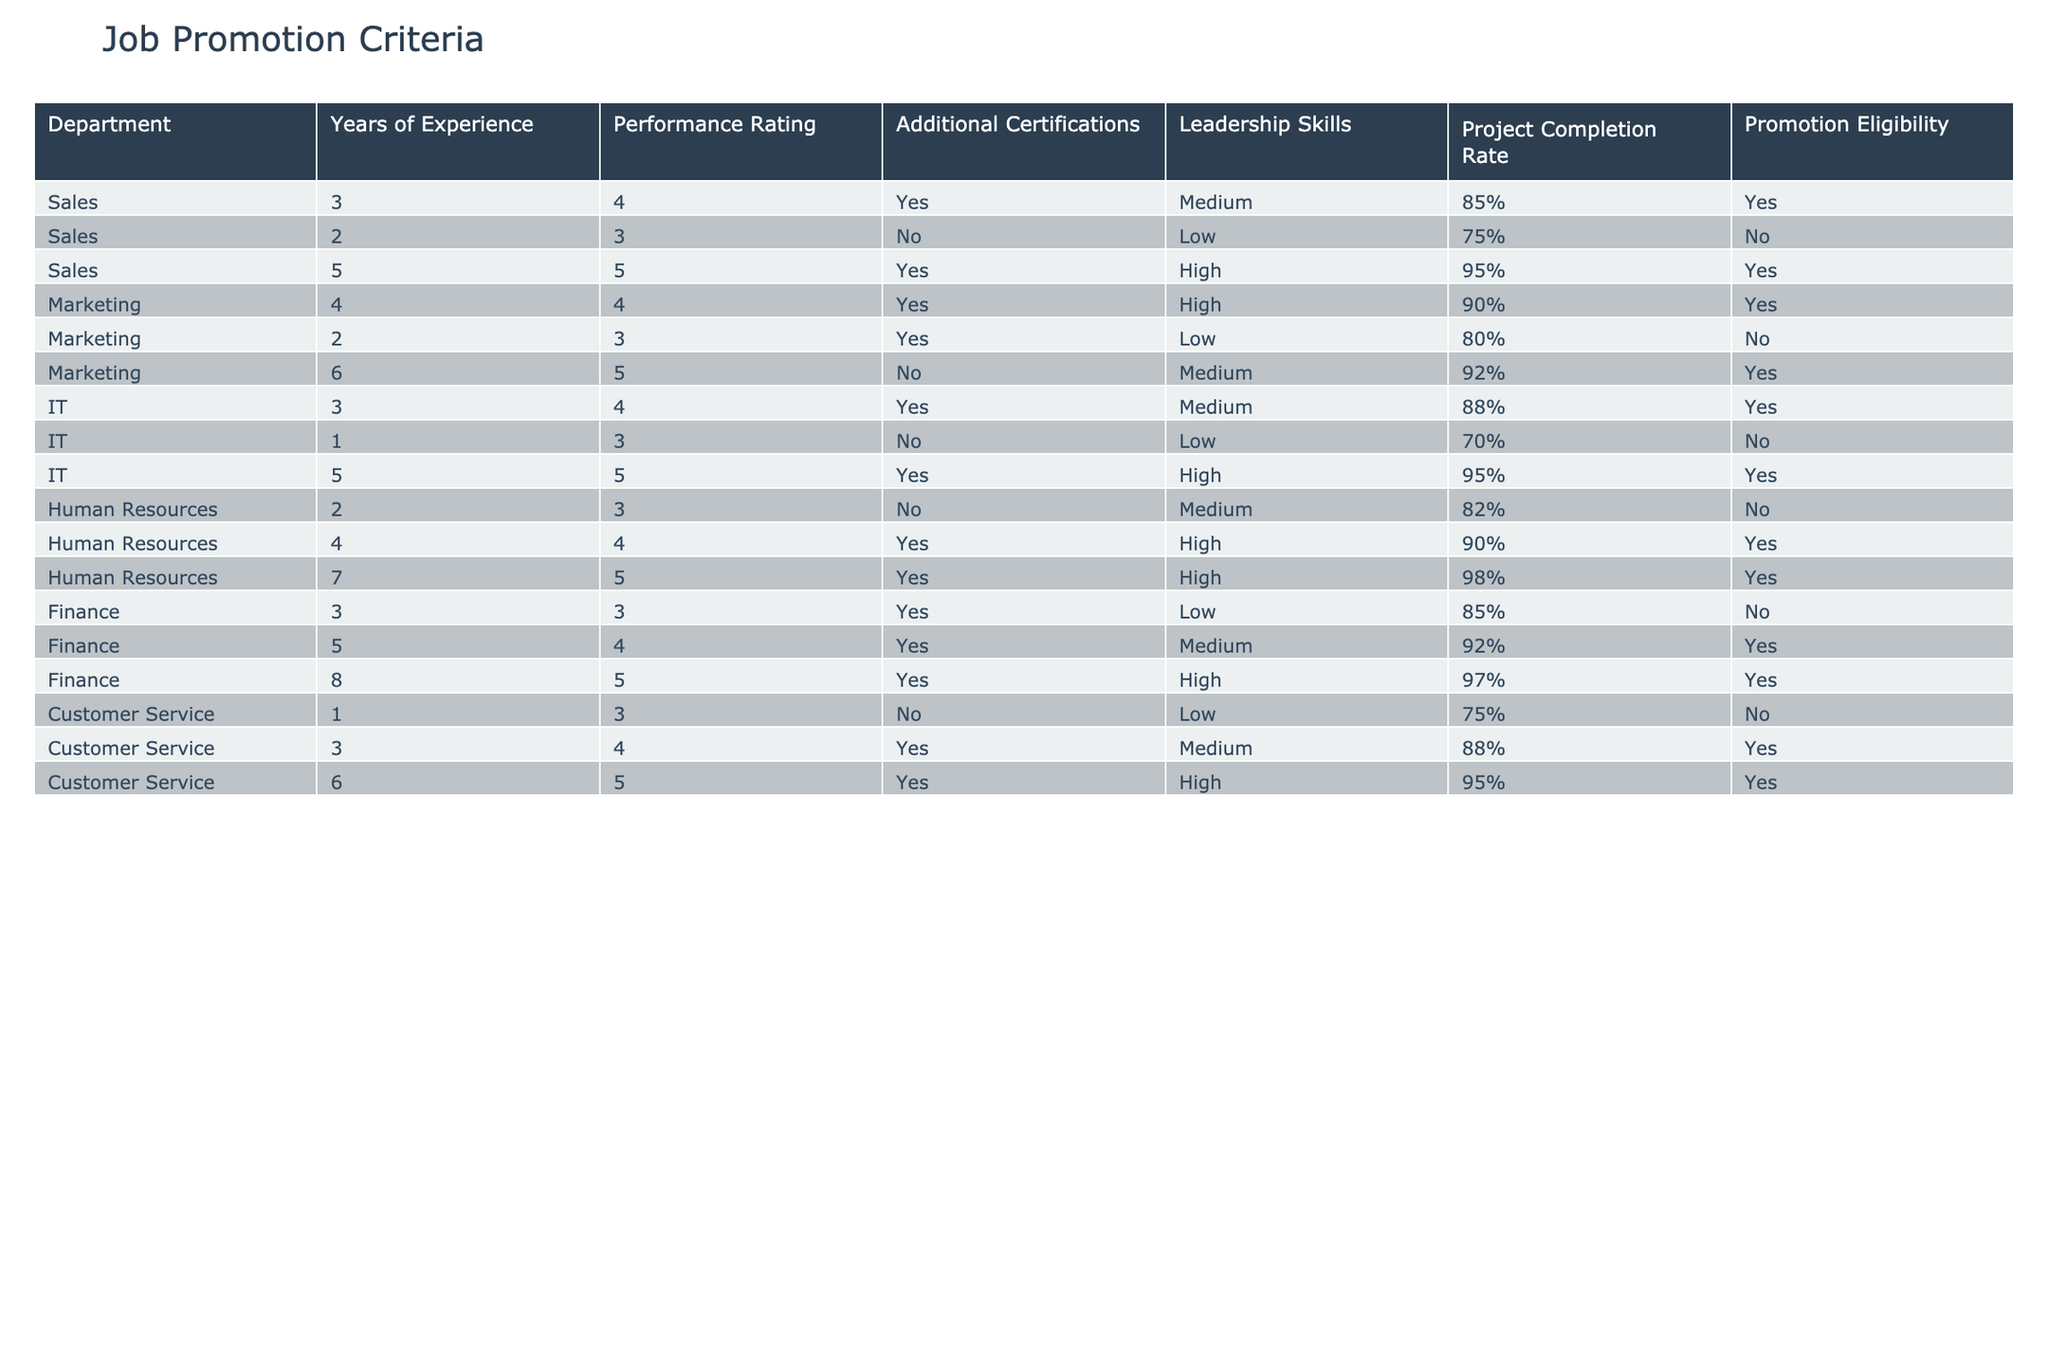What is the promotion eligibility of an employee in the Sales department with 2 years of experience? In the Sales department, the row for 2 years of experience shows that the promotion eligibility is marked as "No."
Answer: No How many employees in the Marketing department are eligible for promotion? In the Marketing department, there are 3 entries: one with 4 years of experience marked as eligible, one with 2 years not eligible, and one with 6 years marked as eligible. Therefore, 2 employees are eligible for promotion.
Answer: 2 Is there any employee in the IT department with 1 year of experience eligible for promotion? The entry for the IT department with 1 year of experience indicates "No" for promotion eligibility.
Answer: No What is the performance rating of the highest-ranked employee in Human Resources? The Human Resources department has three employees with performance ratings of 3, 4, and 5. The highest rating is 5, corresponding to the employee with 7 years of experience.
Answer: 5 For which department does the employee with the highest project completion rate work, and what is that rate? The employee with the highest project completion rate is in the Human Resources department with a completion rate of 98%, based on the last row in that section.
Answer: Human Resources, 98% What is the average project completion rate for employees eligible for promotion across all departments? The eligible employees are from Sales (85%, 95%), Marketing (90%, 92%), IT (88%, 95%), Human Resources (90%, 98%), and Finance (92%, 97%). Summing these rates: 85 + 95 + 90 + 92 + 88 + 95 + 90 + 98 + 92 + 97 = 917, then dividing by 10 gives an average of 91.7%.
Answer: 91.7% Which department has the lowest average performance rating for its employees who are eligible for promotion? Calculating the average for each eligible department, Sales (average 4.5), Marketing (4.5), IT (4.5), Human Resources (4.67), and Finance (4.67). Sales has the lowest average performance rating despite being the same as others.
Answer: Sales How many total years of experience do eligible employees from the Customer Service department have? Customer Service has three eligible employees with 3, 6, and 6 years of experience, totaling 3 + 6 + 6 = 15 years of experience.
Answer: 15 